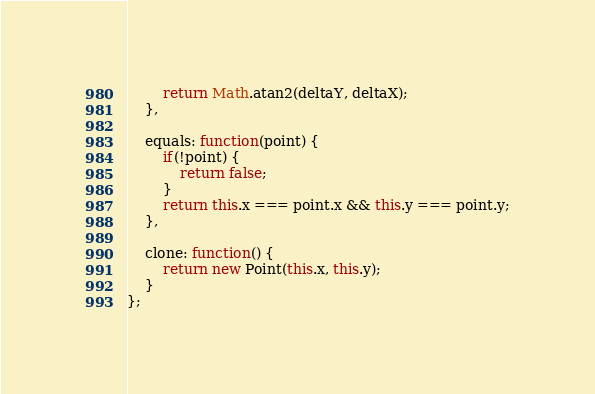<code> <loc_0><loc_0><loc_500><loc_500><_JavaScript_>
        return Math.atan2(deltaY, deltaX);
    },

    equals: function(point) {
        if(!point) {
            return false;
        }
        return this.x === point.x && this.y === point.y;
    },

    clone: function() {
        return new Point(this.x, this.y);
    }
};
</code> 